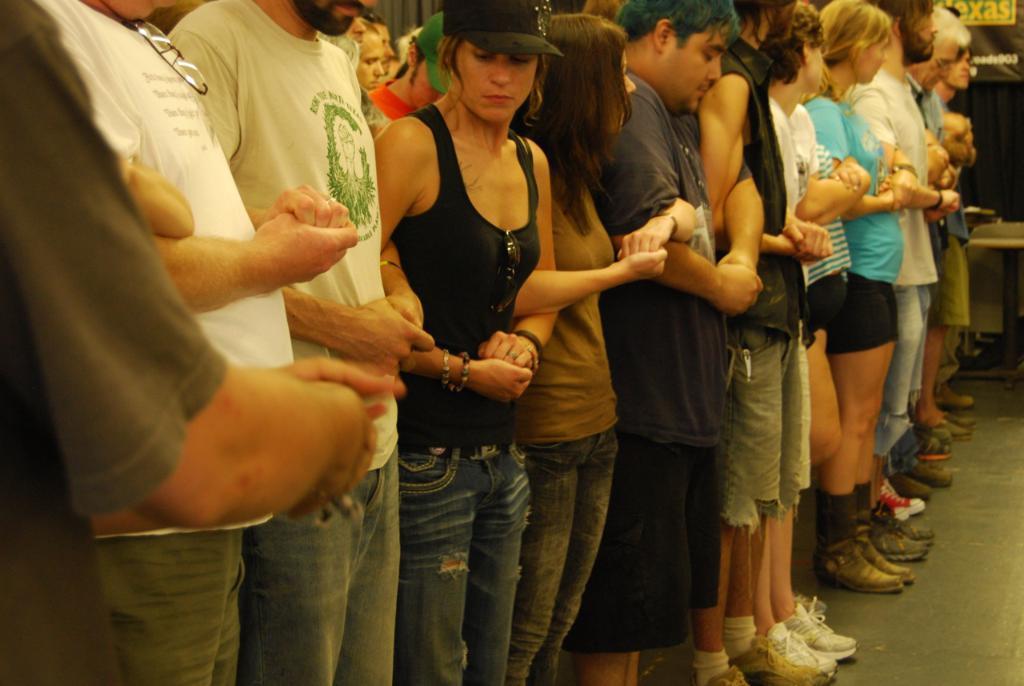How would you summarize this image in a sentence or two? In this image there are people standing and holding the hands of each other. Floor is visible in this image. 